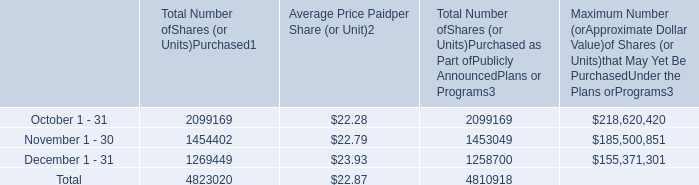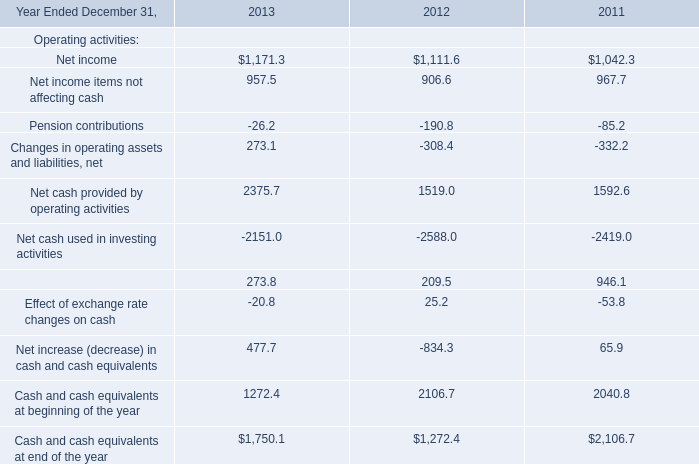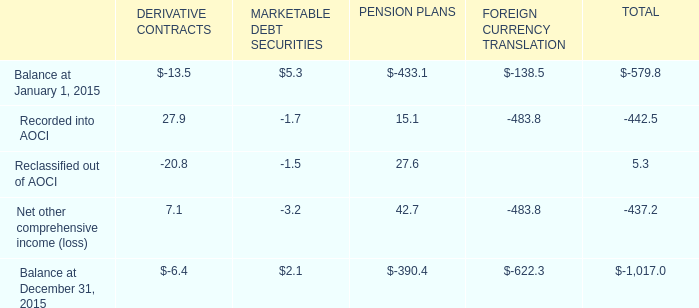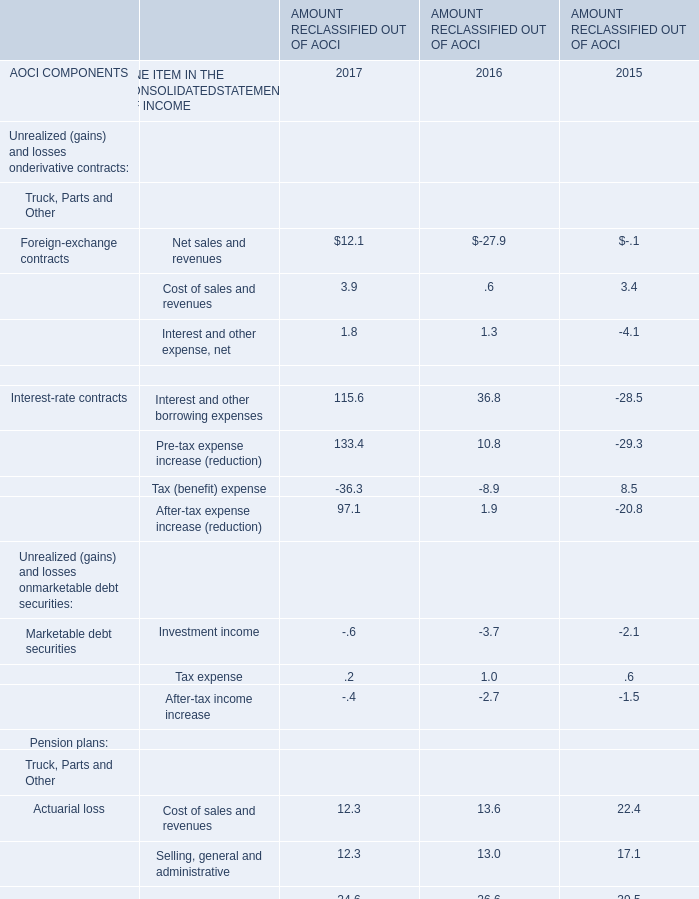how is the treasury stock affected after the stock repurchases in the last three months of 2016 , ( in millions ) ? 
Computations: ((4823020 * 22.87) / 1000000)
Answer: 110.30247. 